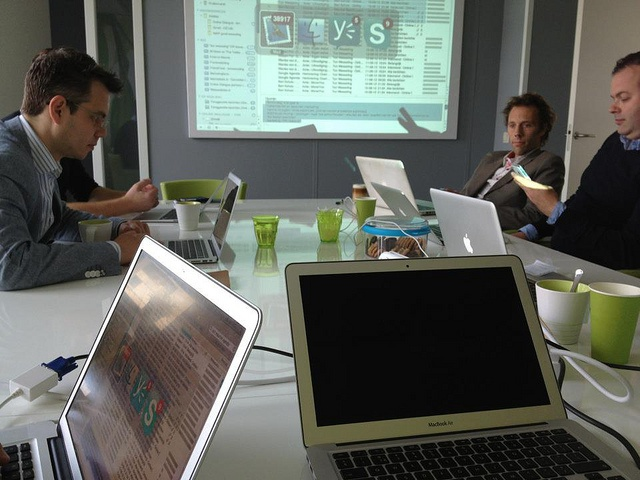Describe the objects in this image and their specific colors. I can see dining table in gray, black, darkgray, and darkgreen tones, laptop in gray, black, and darkgreen tones, tv in gray, lightblue, and darkgray tones, laptop in gray, white, darkgray, and black tones, and people in gray, black, and maroon tones in this image. 